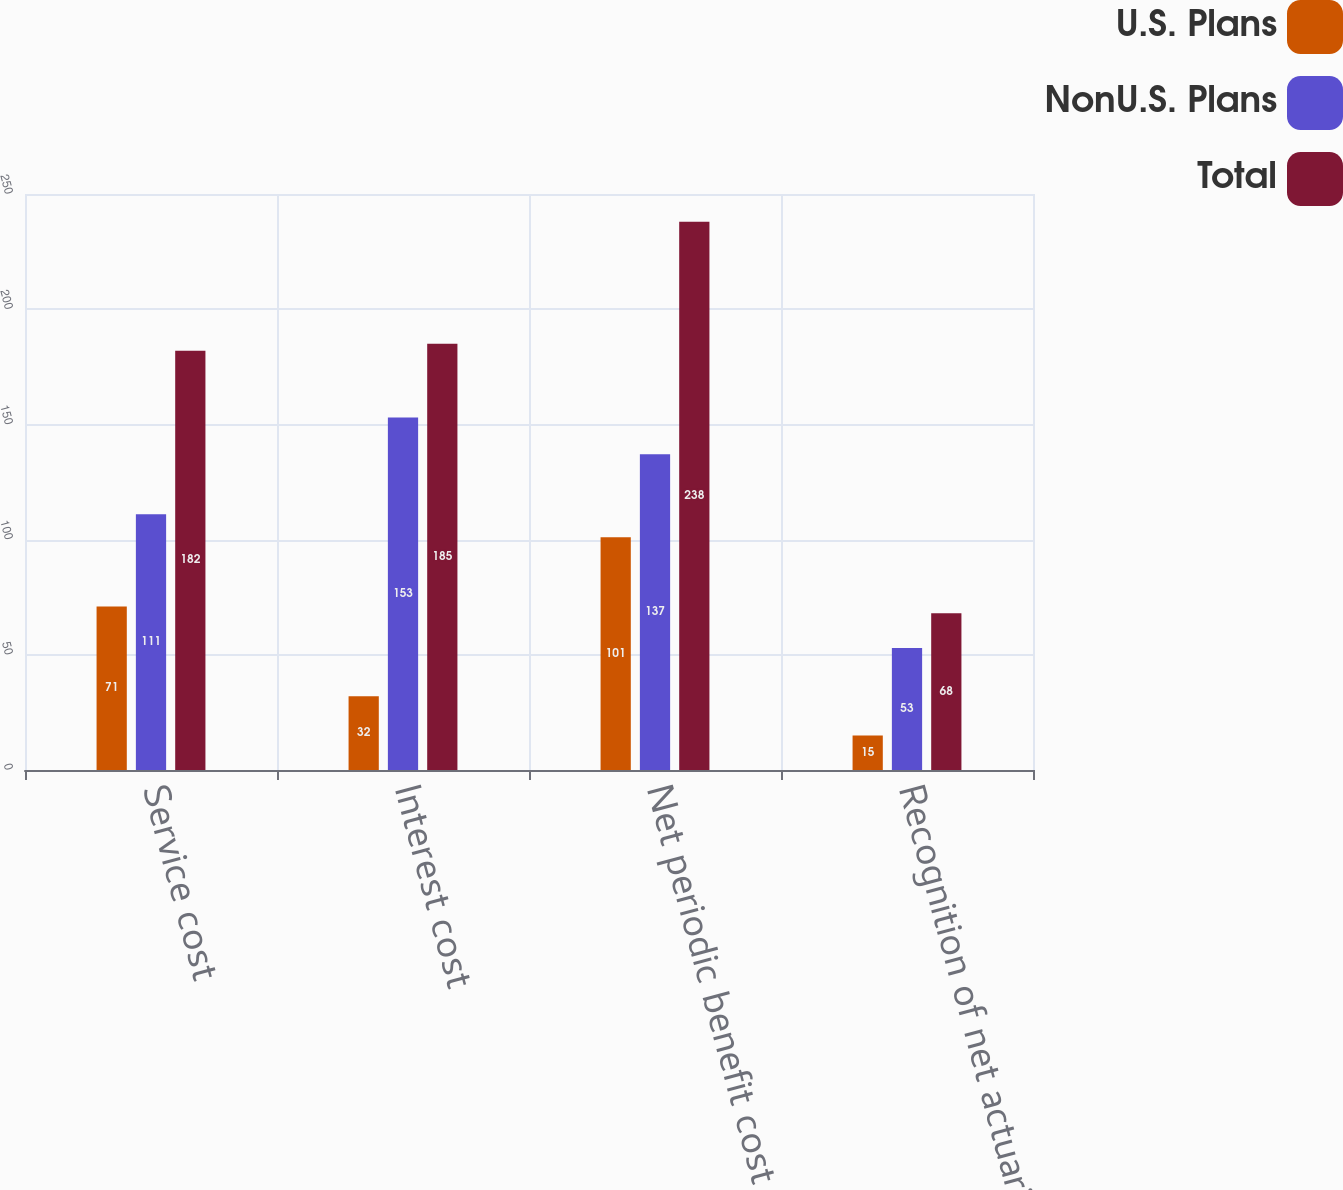Convert chart to OTSL. <chart><loc_0><loc_0><loc_500><loc_500><stacked_bar_chart><ecel><fcel>Service cost<fcel>Interest cost<fcel>Net periodic benefit cost<fcel>Recognition of net actuarial<nl><fcel>U.S. Plans<fcel>71<fcel>32<fcel>101<fcel>15<nl><fcel>NonU.S. Plans<fcel>111<fcel>153<fcel>137<fcel>53<nl><fcel>Total<fcel>182<fcel>185<fcel>238<fcel>68<nl></chart> 